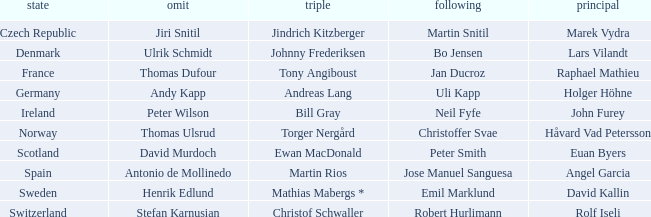In which third did angel garcia lead? Martin Rios. 